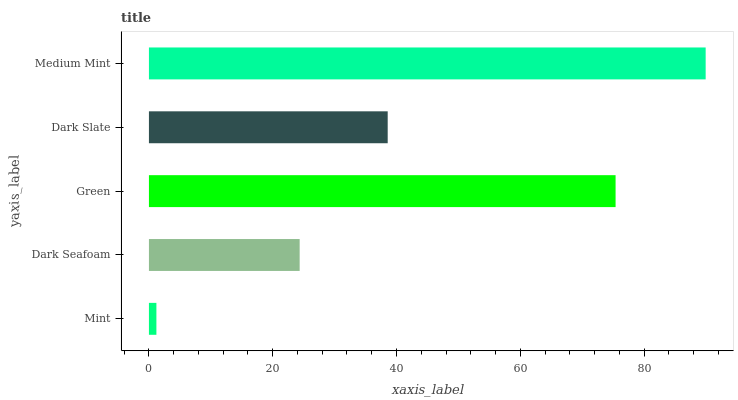Is Mint the minimum?
Answer yes or no. Yes. Is Medium Mint the maximum?
Answer yes or no. Yes. Is Dark Seafoam the minimum?
Answer yes or no. No. Is Dark Seafoam the maximum?
Answer yes or no. No. Is Dark Seafoam greater than Mint?
Answer yes or no. Yes. Is Mint less than Dark Seafoam?
Answer yes or no. Yes. Is Mint greater than Dark Seafoam?
Answer yes or no. No. Is Dark Seafoam less than Mint?
Answer yes or no. No. Is Dark Slate the high median?
Answer yes or no. Yes. Is Dark Slate the low median?
Answer yes or no. Yes. Is Medium Mint the high median?
Answer yes or no. No. Is Dark Seafoam the low median?
Answer yes or no. No. 